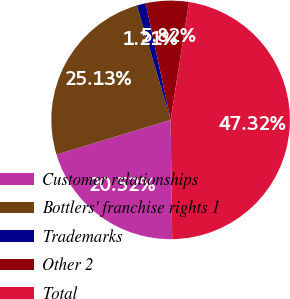<chart> <loc_0><loc_0><loc_500><loc_500><pie_chart><fcel>Customer relationships<fcel>Bottlers' franchise rights 1<fcel>Trademarks<fcel>Other 2<fcel>Total<nl><fcel>20.52%<fcel>25.13%<fcel>1.21%<fcel>5.82%<fcel>47.32%<nl></chart> 